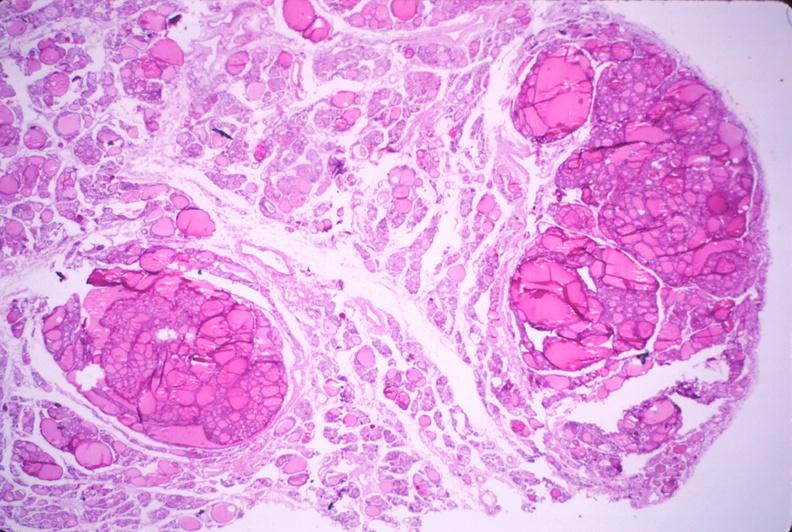does marked show thyroid, nodular hyperplasia?
Answer the question using a single word or phrase. No 